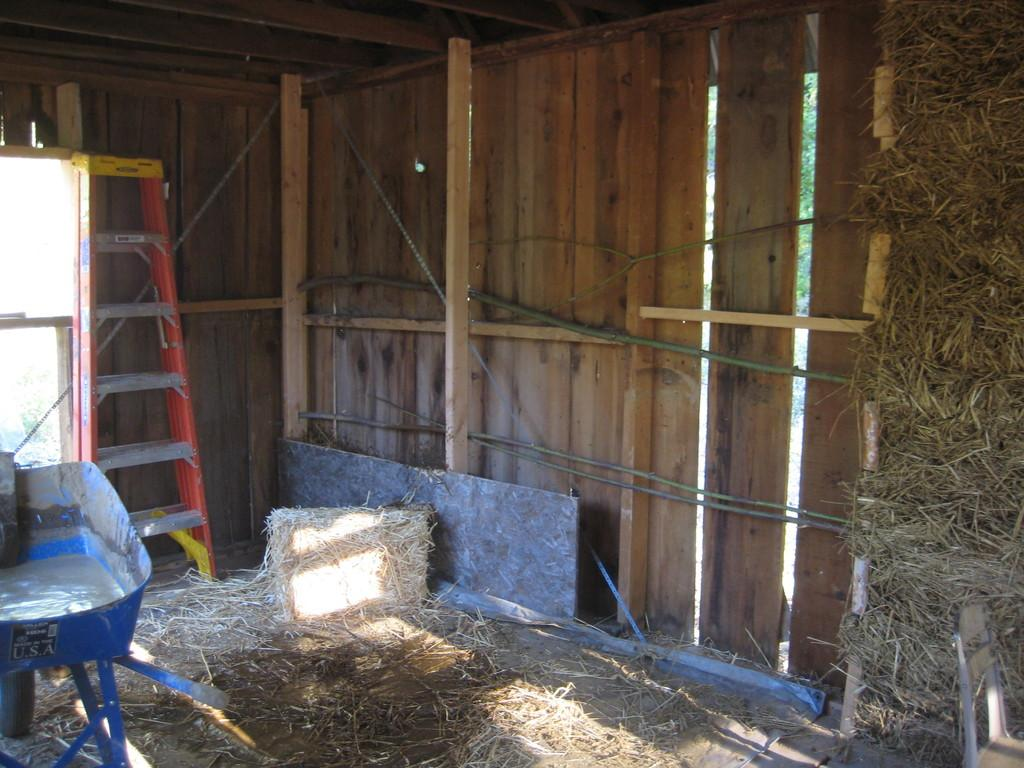What type of structure might the image be taken inside? The image might be taken inside a shelter. What material is used for the wall in the image? There is a wooden wall in the image. What other wooden structures can be seen in the image? There are wooden poles in the image. What is used for climbing in the image? There is a ladder in the image. What type of vegetation is present in the image? Grass is present in the image. How many pigs are visible in the image? There are no pigs present in the image. What type of fan is used to cool the shelter in the image? There is no fan visible in the image. 